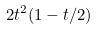<formula> <loc_0><loc_0><loc_500><loc_500>2 t ^ { 2 } ( 1 - t / 2 )</formula> 